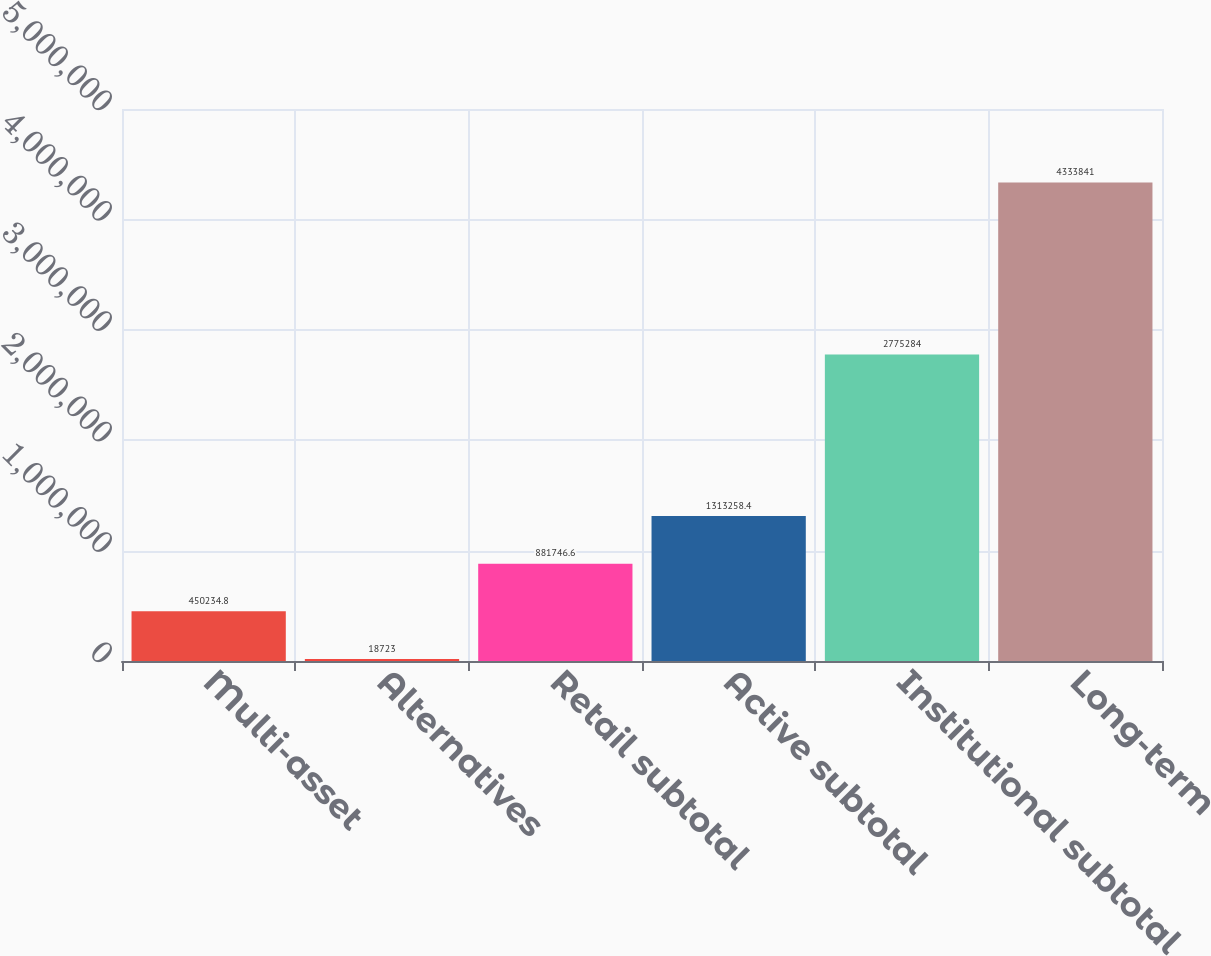<chart> <loc_0><loc_0><loc_500><loc_500><bar_chart><fcel>Multi-asset<fcel>Alternatives<fcel>Retail subtotal<fcel>Active subtotal<fcel>Institutional subtotal<fcel>Long-term<nl><fcel>450235<fcel>18723<fcel>881747<fcel>1.31326e+06<fcel>2.77528e+06<fcel>4.33384e+06<nl></chart> 